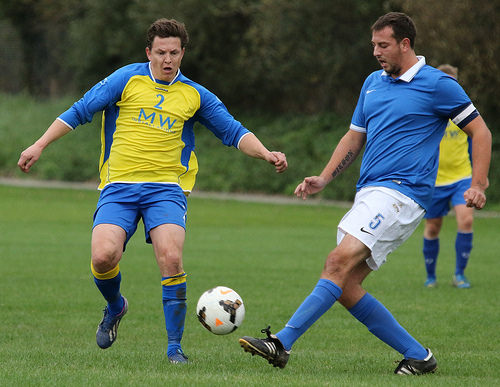<image>
Is there a ball in front of the shoe? Yes. The ball is positioned in front of the shoe, appearing closer to the camera viewpoint. 